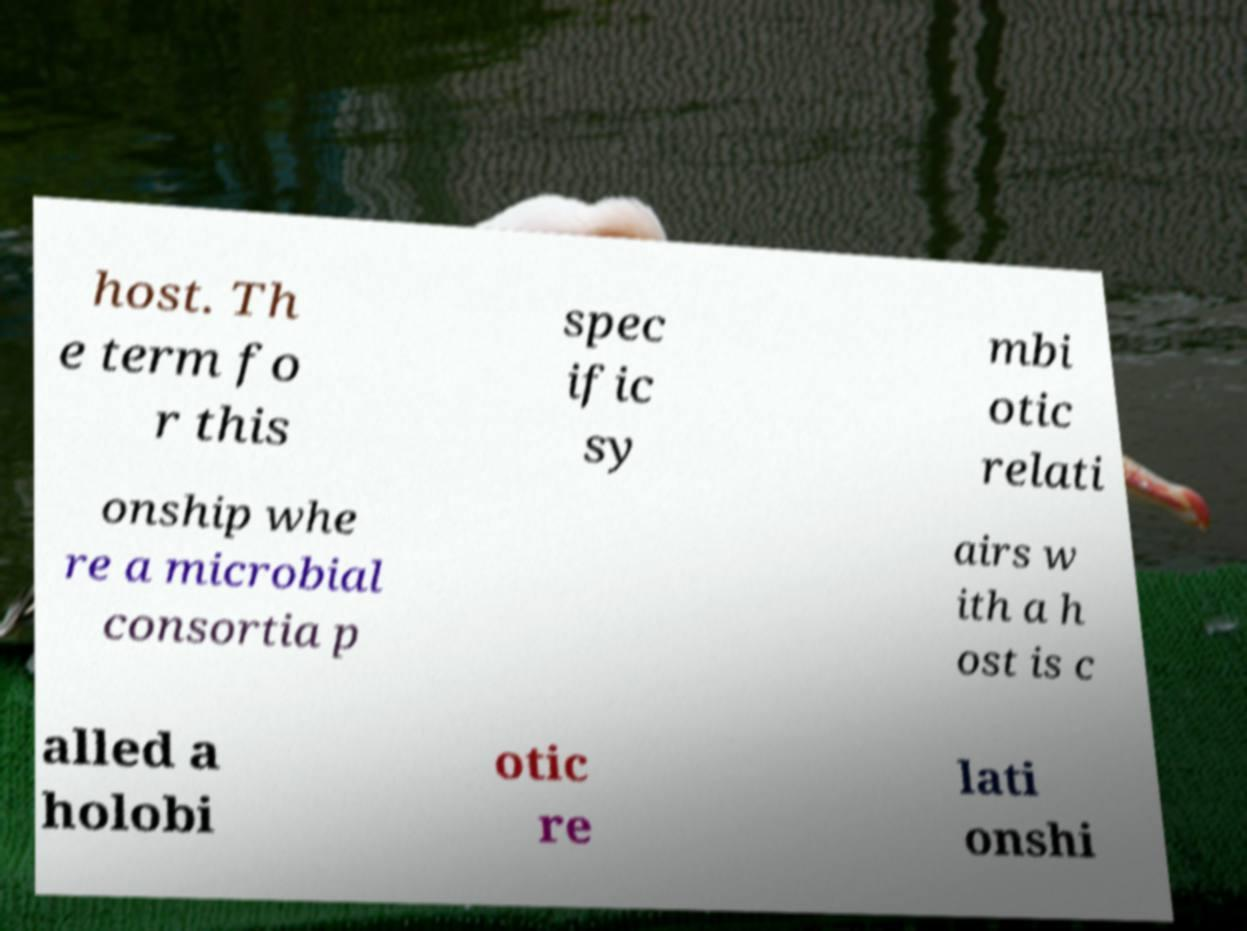There's text embedded in this image that I need extracted. Can you transcribe it verbatim? host. Th e term fo r this spec ific sy mbi otic relati onship whe re a microbial consortia p airs w ith a h ost is c alled a holobi otic re lati onshi 